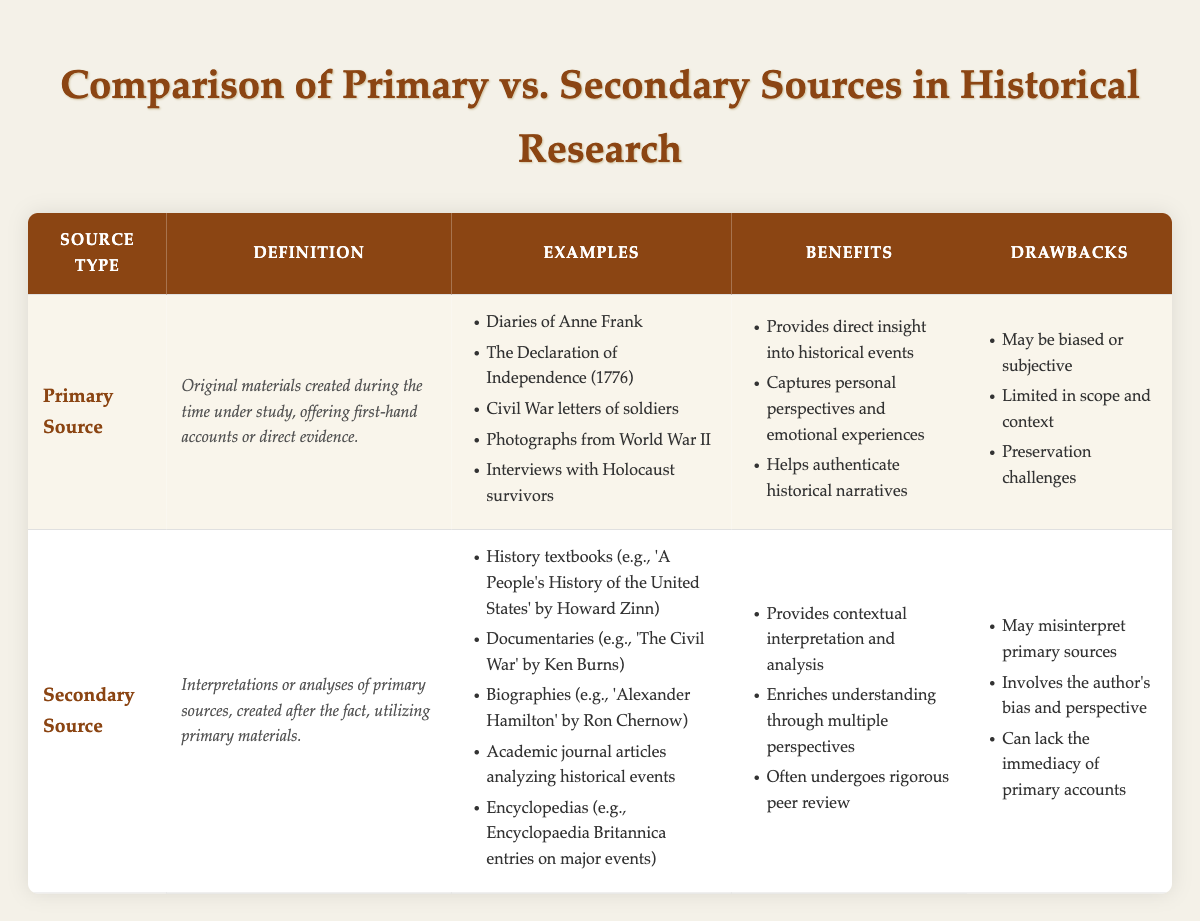What type of source provides first-hand accounts or direct evidence? According to the table, a "Primary Source" is defined as original materials created during the time under study, offering first-hand accounts or direct evidence.
Answer: Primary Source Which historical document from 1776 is listed as an example of a primary source? The table lists "The Declaration of Independence (1776)" as an example of a primary source, which fits the query about a historical document from that year.
Answer: The Declaration of Independence (1776) Do secondary sources help provide contextual interpretation and analysis? Yes, the table indicates that secondary sources provide contextual interpretation and analysis, as stated in their benefits section.
Answer: Yes How many examples of primary sources are provided in the table? The table lists five examples of primary sources: "Diaries of Anne Frank," "The Declaration of Independence (1776)," "Civil War letters of soldiers," "Photographs from World War II," and "Interviews with Holocaust survivors." Therefore, the count is five.
Answer: 5 What are the drawbacks of secondary sources according to the table? The table outlines three drawbacks of secondary sources: they may misinterpret primary sources, involve the author's bias and perspective, and can lack the immediacy of primary accounts.
Answer: They may misinterpret primary sources, involve author's bias, lack immediacy What is the total number of benefits listed for primary sources? The table states three benefits of primary sources: they provide direct insight into historical events, capture personal perspectives and emotional experiences, and help authenticate historical narratives. Therefore, the total number is three.
Answer: 3 Is it true that biographies are considered primary sources? No, the table categorizes biographies as examples of secondary sources, which interpret or analyze primary sources rather than providing original evidence.
Answer: No What is the difference in the number of benefits between primary and secondary sources? The table lists three benefits for primary sources and three benefits for secondary sources. Therefore, the difference is zero, as they both have the same number of benefits.
Answer: 0 